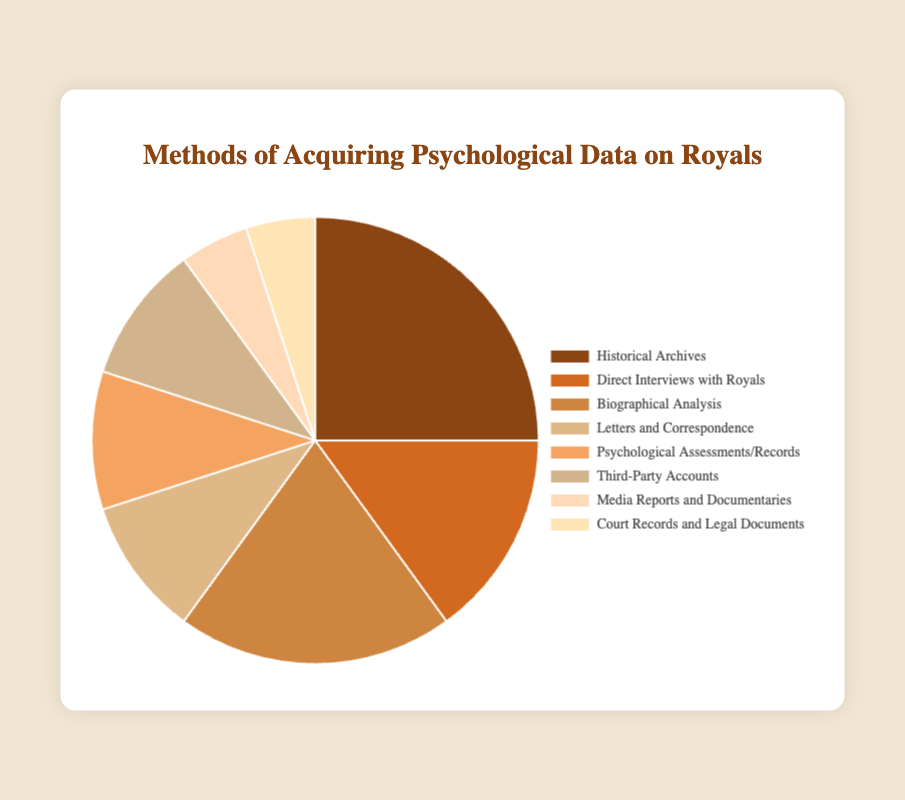Which method is used the most for acquiring psychological data on royals? The method with the highest percentage in the figure is "Historical Archives" at 25%. This percentage indicates it's the most used method.
Answer: Historical Archives Which two methods have equal percentages in the pie chart? Both "Psychological Assessments/Records" and "Third-Party Accounts" have the same percentage, 10%. By looking at the figure, these segments are visually the same size.
Answer: Psychological Assessments/Records and Third-Party Accounts What is the combined percentage of "Letters and Correspondence" and "Media Reports and Documentaries"? "Letters and Correspondence" makes up 10% and "Media Reports and Documentaries" makes up 5%. Adding these together gives 10% + 5% = 15%.
Answer: 15% Is the percentage of "Direct Interviews with Royals" greater or less than "Biographical Analysis"? "Direct Interviews with Royals" is 15%, while "Biographical Analysis" is 20%. Comparing these percentages, "Direct Interviews with Royals" is less.
Answer: Less By how much does the percentage of "Historical Archives" exceed "Court Records and Legal Documents"? "Historical Archives" has 25% and "Court Records and Legal Documents" has 5%. The difference is 25% - 5% = 20%.
Answer: 20% What is the average percentage of "Psychological Assessments/Records", "Third-Party Accounts", and "Court Records and Legal Documents"? These methods have percentages of 10%, 10%, and 5%, respectively. Adding these gives 10 + 10 + 5 = 25, and then dividing by 3 yields an average of 25/3 ≈ 8.33%.
Answer: 8.33% Which methods have a percentage less than 10%? The methods with percentages less than 10% are "Media Reports and Documentaries" and "Court Records and Legal Documents" at 5% each.
Answer: Media Reports and Documentaries, Court Records and Legal Documents What proportion of the pie chart is taken up by "Historical Archives", "Direct Interviews with Royals", and "Biographical Analysis" combined? Summing their percentages: 25% (Historical Archives) + 15% (Direct Interviews) + 20% (Biographical Analysis) = 60%.
Answer: 60% What visual feature indicates that the largest segment represents "Historical Archives"? The "Historical Archives" segment is the largest in area, making it visibly distinct as the most significant part of the pie chart.
Answer: Largest segment How much greater is the combined percentage of "Biographical Analysis" and "Historical Archives" compared to "Direct Interviews with Royals"? "Biographical Analysis" is 20% and "Historical Archives" is 25%, totaling 45%. "Direct Interviews with Royals" is 15%. The difference is 45% - 15% = 30%.
Answer: 30% 